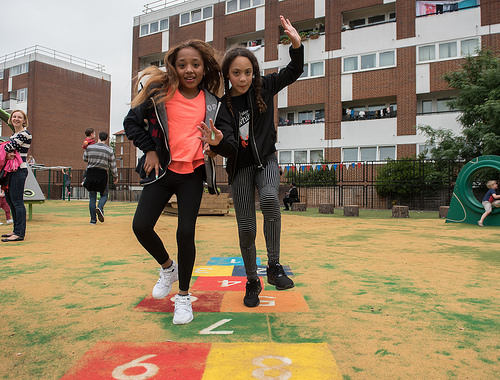<image>
Is there a shirt on the girl? No. The shirt is not positioned on the girl. They may be near each other, but the shirt is not supported by or resting on top of the girl. Is the woman in front of the girl? No. The woman is not in front of the girl. The spatial positioning shows a different relationship between these objects. 